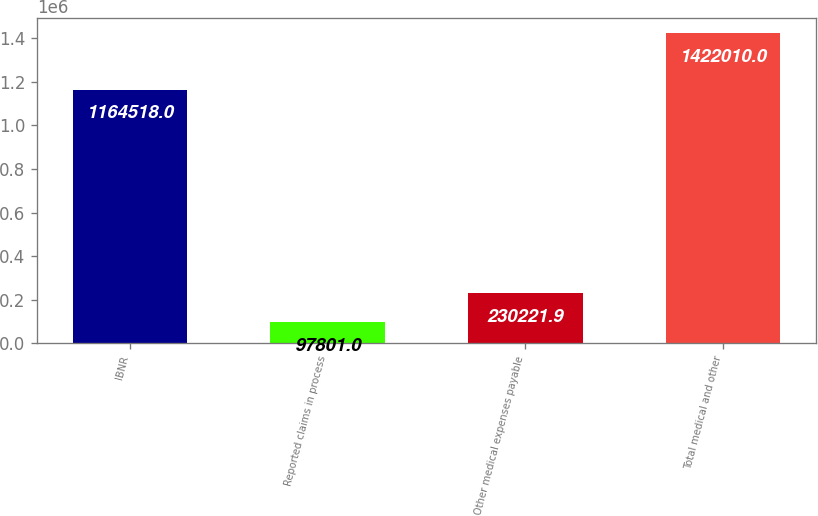Convert chart. <chart><loc_0><loc_0><loc_500><loc_500><bar_chart><fcel>IBNR<fcel>Reported claims in process<fcel>Other medical expenses payable<fcel>Total medical and other<nl><fcel>1.16452e+06<fcel>97801<fcel>230222<fcel>1.42201e+06<nl></chart> 